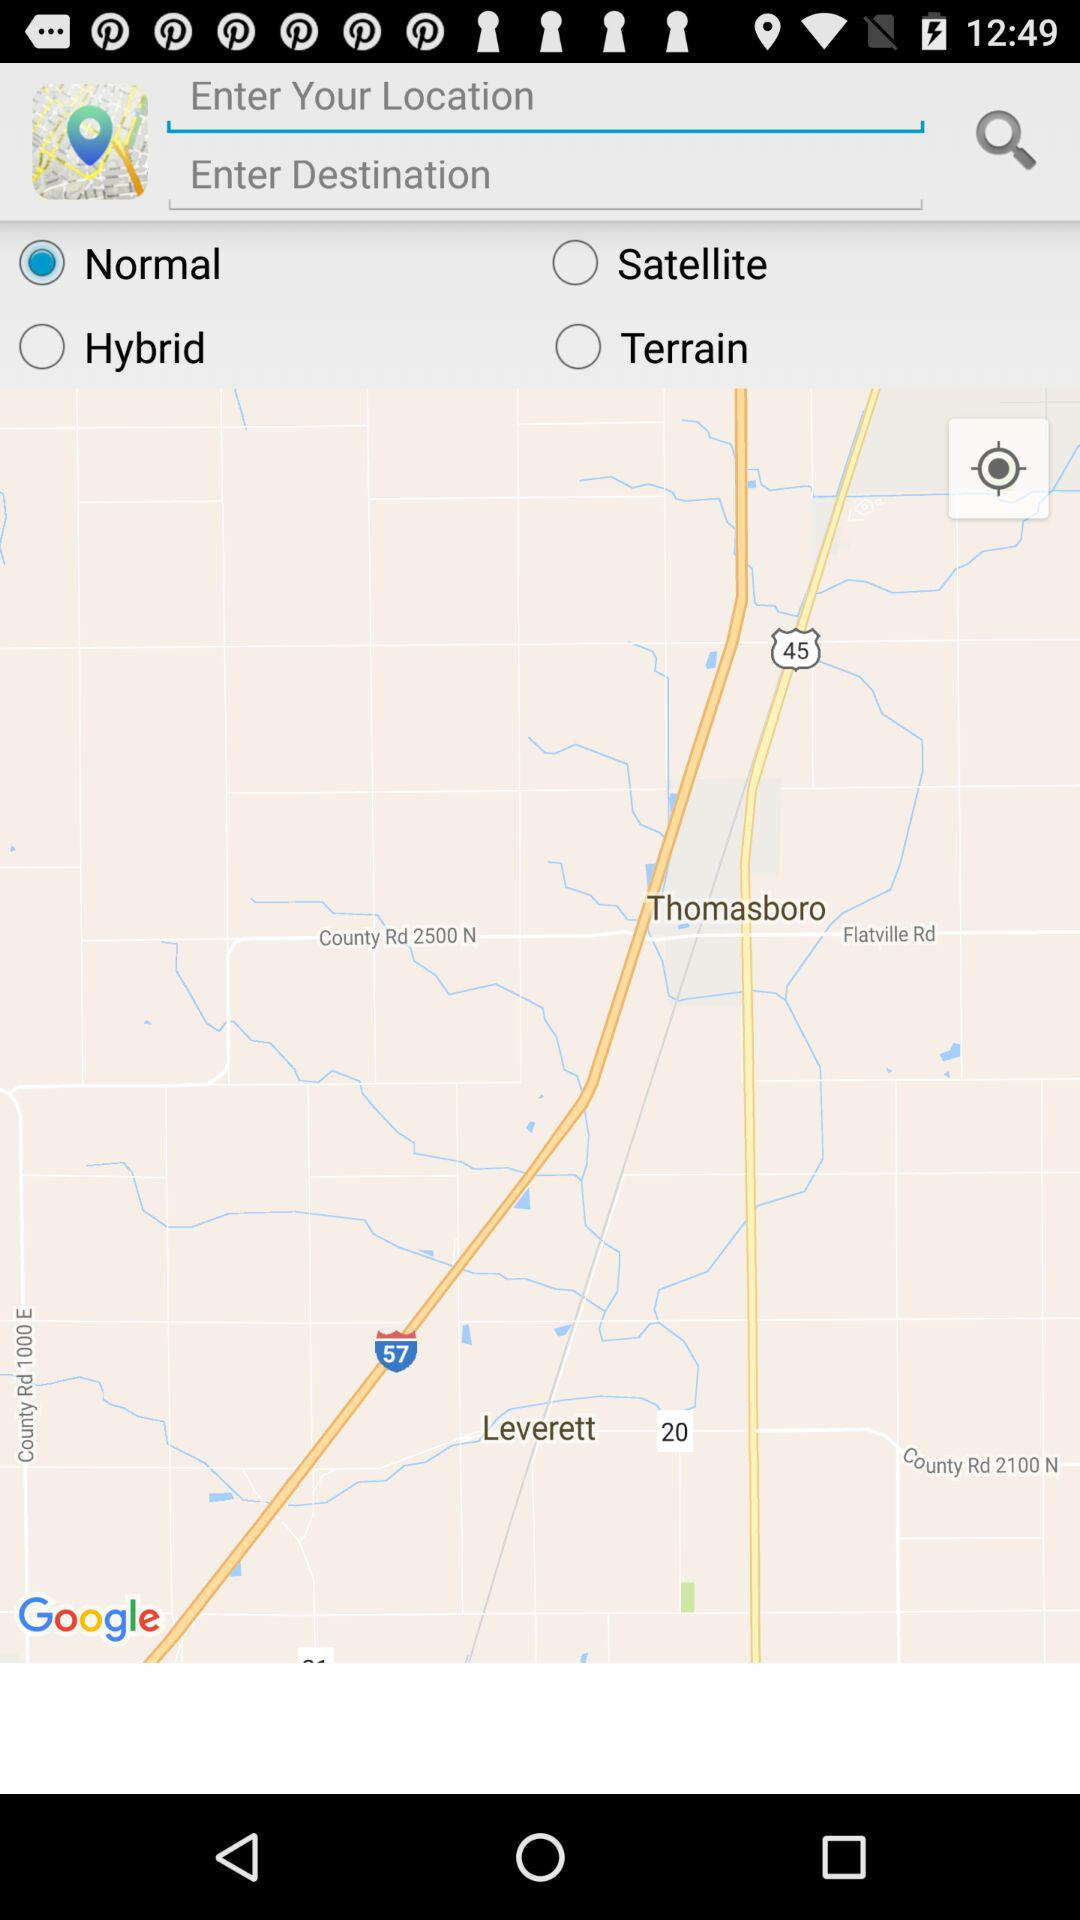Which option has been selected? The selected option is "Normal". 